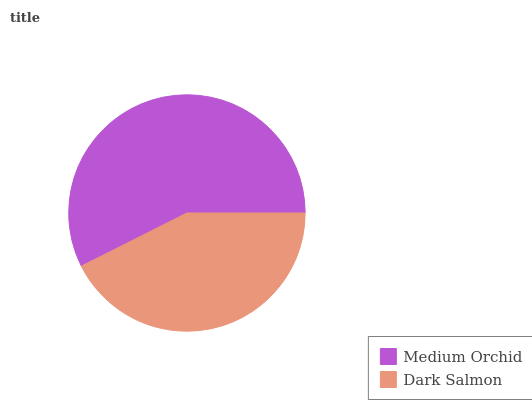Is Dark Salmon the minimum?
Answer yes or no. Yes. Is Medium Orchid the maximum?
Answer yes or no. Yes. Is Dark Salmon the maximum?
Answer yes or no. No. Is Medium Orchid greater than Dark Salmon?
Answer yes or no. Yes. Is Dark Salmon less than Medium Orchid?
Answer yes or no. Yes. Is Dark Salmon greater than Medium Orchid?
Answer yes or no. No. Is Medium Orchid less than Dark Salmon?
Answer yes or no. No. Is Medium Orchid the high median?
Answer yes or no. Yes. Is Dark Salmon the low median?
Answer yes or no. Yes. Is Dark Salmon the high median?
Answer yes or no. No. Is Medium Orchid the low median?
Answer yes or no. No. 